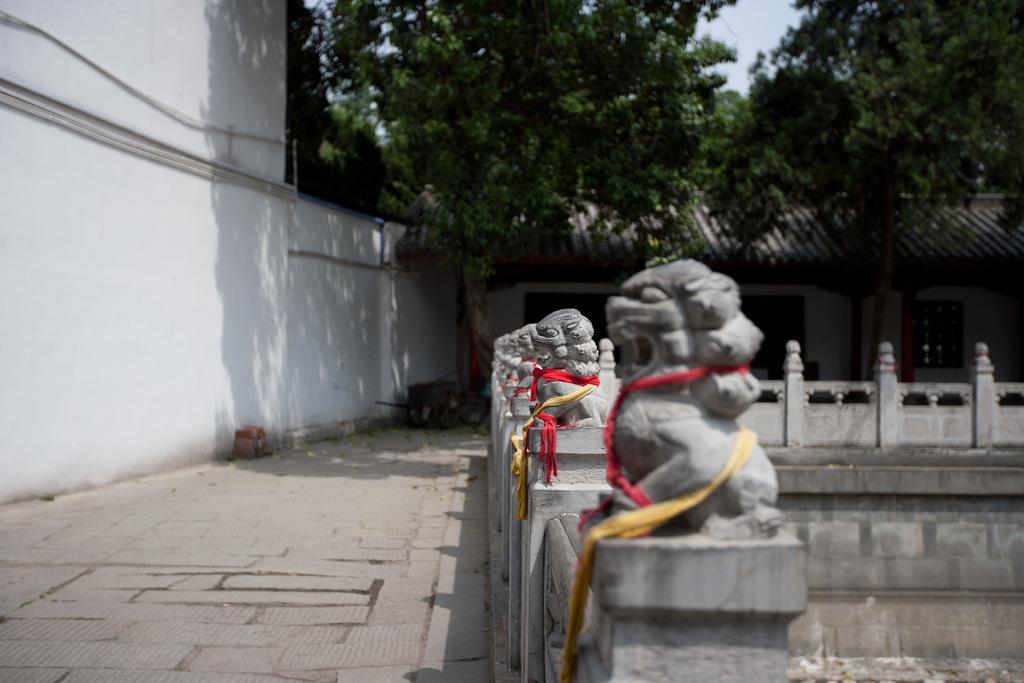Describe this image in one or two sentences. In this image I can see the statues. To the left I can see the wall. In the background I can see the shed, many trees and the sky. 